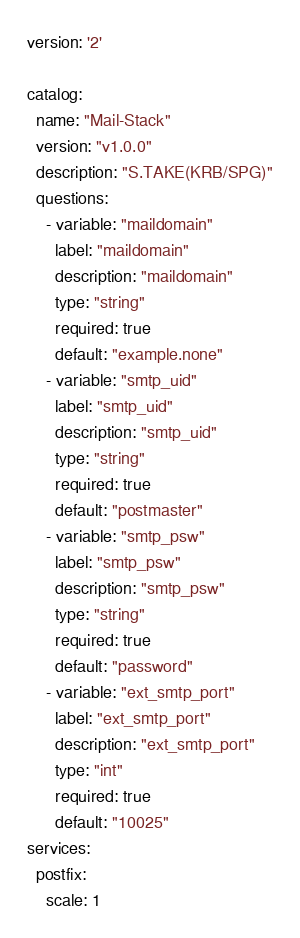Convert code to text. <code><loc_0><loc_0><loc_500><loc_500><_YAML_>version: '2'

catalog:
  name: "Mail-Stack"
  version: "v1.0.0"
  description: "S.TAKE(KRB/SPG)"
  questions:
    - variable: "maildomain"
      label: "maildomain"
      description: "maildomain"
      type: "string"
      required: true
      default: "example.none"
    - variable: "smtp_uid"
      label: "smtp_uid"
      description: "smtp_uid"
      type: "string"
      required: true
      default: "postmaster"
    - variable: "smtp_psw"
      label: "smtp_psw"
      description: "smtp_psw"
      type: "string"
      required: true
      default: "password"
    - variable: "ext_smtp_port"
      label: "ext_smtp_port"
      description: "ext_smtp_port"
      type: "int"
      required: true
      default: "10025"
services:
  postfix:
    scale: 1
</code> 